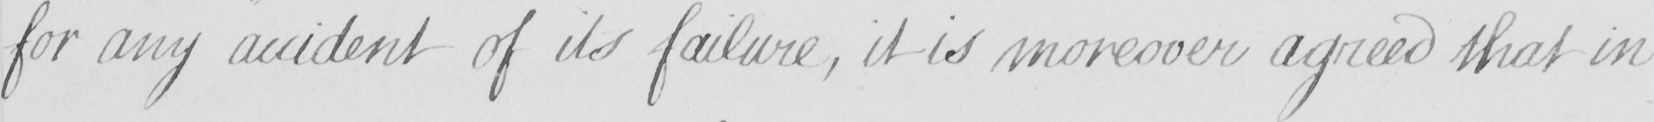Please provide the text content of this handwritten line. for any accident of its failure , it is moreover agreed that in 